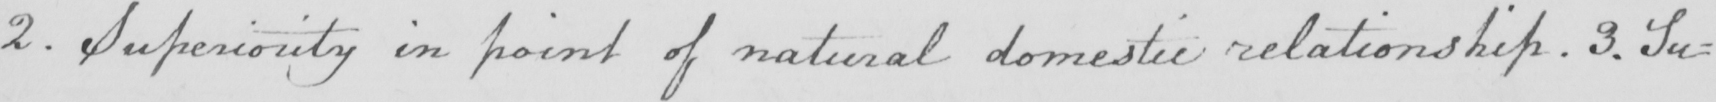Can you tell me what this handwritten text says? 2 . Superiority in point of natural domestic relationship . 3 . Su : 